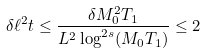<formula> <loc_0><loc_0><loc_500><loc_500>\delta \ell ^ { 2 } t \leq \frac { \delta M _ { 0 } ^ { 2 } T _ { 1 } } { L ^ { 2 } \log ^ { 2 s } ( M _ { 0 } T _ { 1 } ) } \leq 2</formula> 